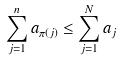<formula> <loc_0><loc_0><loc_500><loc_500>\sum _ { j = 1 } ^ { n } a _ { \pi ( j ) } \leq \sum _ { j = 1 } ^ { N } a _ { j }</formula> 